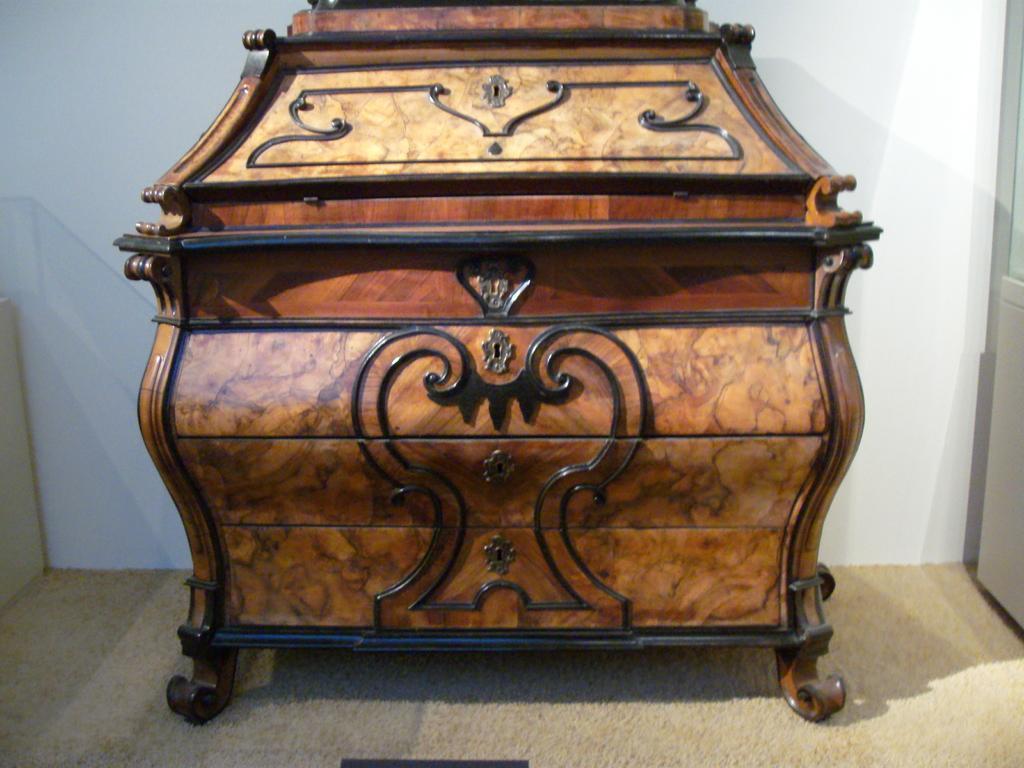Describe this image in one or two sentences. In this image, we can see a wooden box, in the background there is a white color wall. 